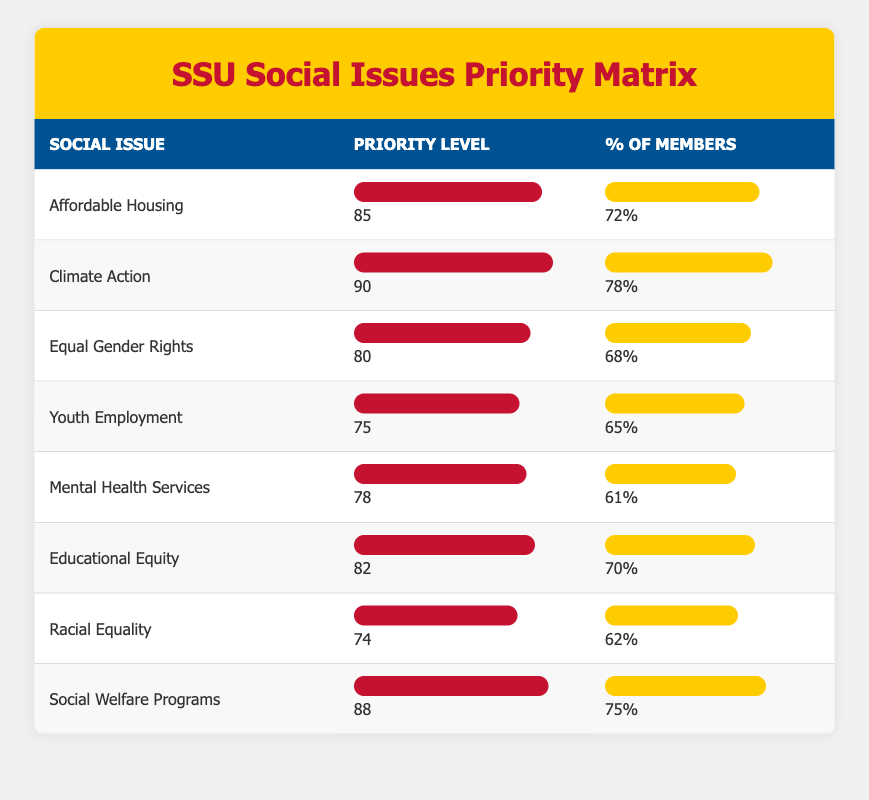What's the priority level for Affordable Housing? The table lists Affordable Housing under the "Priority Level" column, which shows the value of 85.
Answer: 85 What percentage of SSU members prioritize Climate Action? According to the table, Climate Action has a percentage of members listed as 78% under the "% of Members" column.
Answer: 78% Which social issue has the highest priority level? By examining the "Priority Level" column, Climate Action has the highest value of 90, making it the top priority issue.
Answer: Climate Action What is the average priority level for all social issues? Adding the priority levels (85 + 90 + 80 + 75 + 78 + 82 + 74 + 88 = 682) and dividing by the number of issues (8) gives an average of 682/8 = 85.25.
Answer: 85.25 Are more members concerned about Mental Health Services than Racial Equality? The percentage of members prioritizing Mental Health Services is 61%, while for Racial Equality it is 62%. Since 61% is less than 62%, the statement is false.
Answer: No What is the difference in the percentage of members prioritizing Educational Equity and Youth Employment? Educational Equity has 70%, and Youth Employment has 65%. The difference is calculated as 70% - 65% = 5%.
Answer: 5% How many social issues have a priority level greater than 80? The social issues with a priority level greater than 80 are Climate Action (90), Affordable Housing (85), Educational Equity (82), and Social Welfare Programs (88). That's a total of 4 issues.
Answer: 4 Which social issue has the lowest percentage of members prioritizing it? By looking at the "% of Members" column, Mental Health Services has the lowest percentage of members at 61%.
Answer: Mental Health Services How does the priority level of Youth Employment compare to that of Racial Equality? Youth Employment has a priority level of 75, while Racial Equality has a level of 74. Since 75 is greater than 74, Youth Employment has a higher priority level.
Answer: Youth Employment is higher Are the majority of SSU members prioritizing Social Welfare Programs? The table shows that Social Welfare Programs have 75% of members prioritizing it. Since this is greater than 50%, the majority expresses this priority.
Answer: Yes 